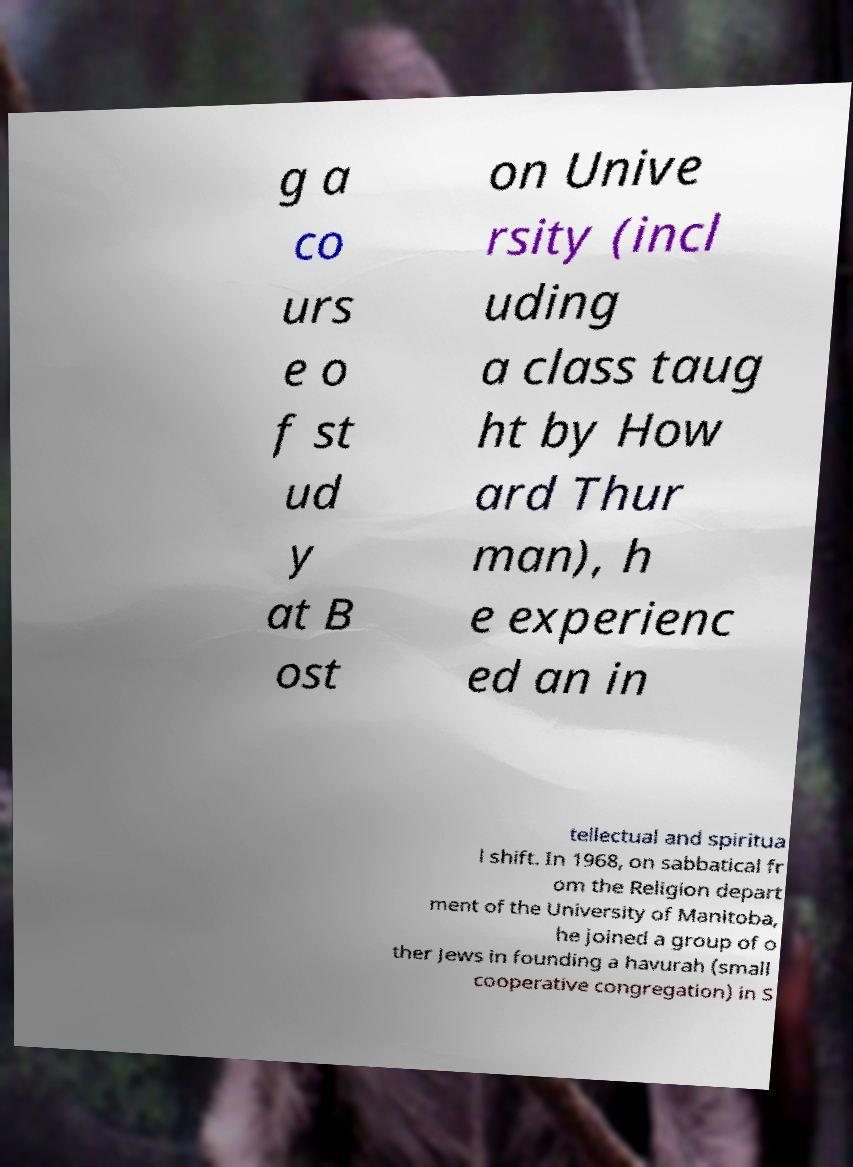Could you assist in decoding the text presented in this image and type it out clearly? g a co urs e o f st ud y at B ost on Unive rsity (incl uding a class taug ht by How ard Thur man), h e experienc ed an in tellectual and spiritua l shift. In 1968, on sabbatical fr om the Religion depart ment of the University of Manitoba, he joined a group of o ther Jews in founding a havurah (small cooperative congregation) in S 